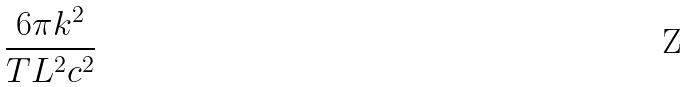<formula> <loc_0><loc_0><loc_500><loc_500>\frac { 6 \pi k ^ { 2 } } { T L ^ { 2 } c ^ { 2 } }</formula> 